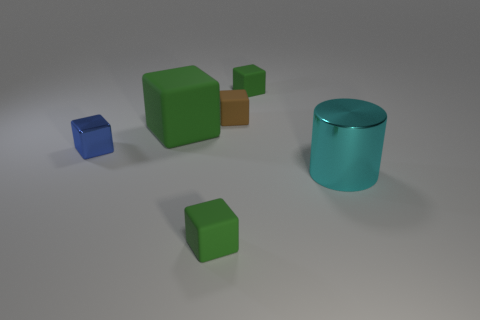Subtract all yellow spheres. How many green cubes are left? 3 Subtract 1 cubes. How many cubes are left? 4 Subtract all small blue cubes. How many cubes are left? 4 Add 2 tiny green matte cubes. How many objects exist? 8 Subtract all brown cubes. How many cubes are left? 4 Subtract all blue blocks. Subtract all purple cylinders. How many blocks are left? 4 Subtract all cylinders. How many objects are left? 5 Subtract all tiny brown blocks. Subtract all small blue rubber cylinders. How many objects are left? 5 Add 2 big blocks. How many big blocks are left? 3 Add 6 tiny blue things. How many tiny blue things exist? 7 